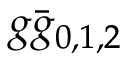Convert formula to latex. <formula><loc_0><loc_0><loc_500><loc_500>g \bar { g } _ { 0 , 1 , 2 }</formula> 